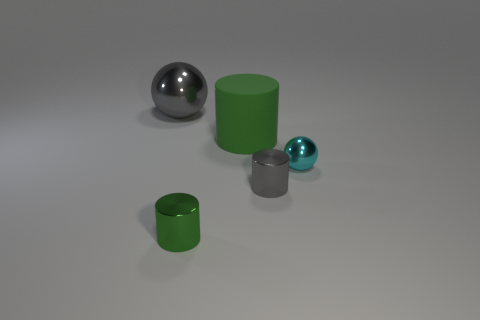Subtract all metallic cylinders. How many cylinders are left? 1 Add 3 large matte objects. How many objects exist? 8 Subtract all cylinders. How many objects are left? 2 Add 1 tiny metal balls. How many tiny metal balls are left? 2 Add 5 small cyan shiny spheres. How many small cyan shiny spheres exist? 6 Subtract 0 brown cylinders. How many objects are left? 5 Subtract all large green balls. Subtract all cyan balls. How many objects are left? 4 